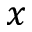Convert formula to latex. <formula><loc_0><loc_0><loc_500><loc_500>x</formula> 